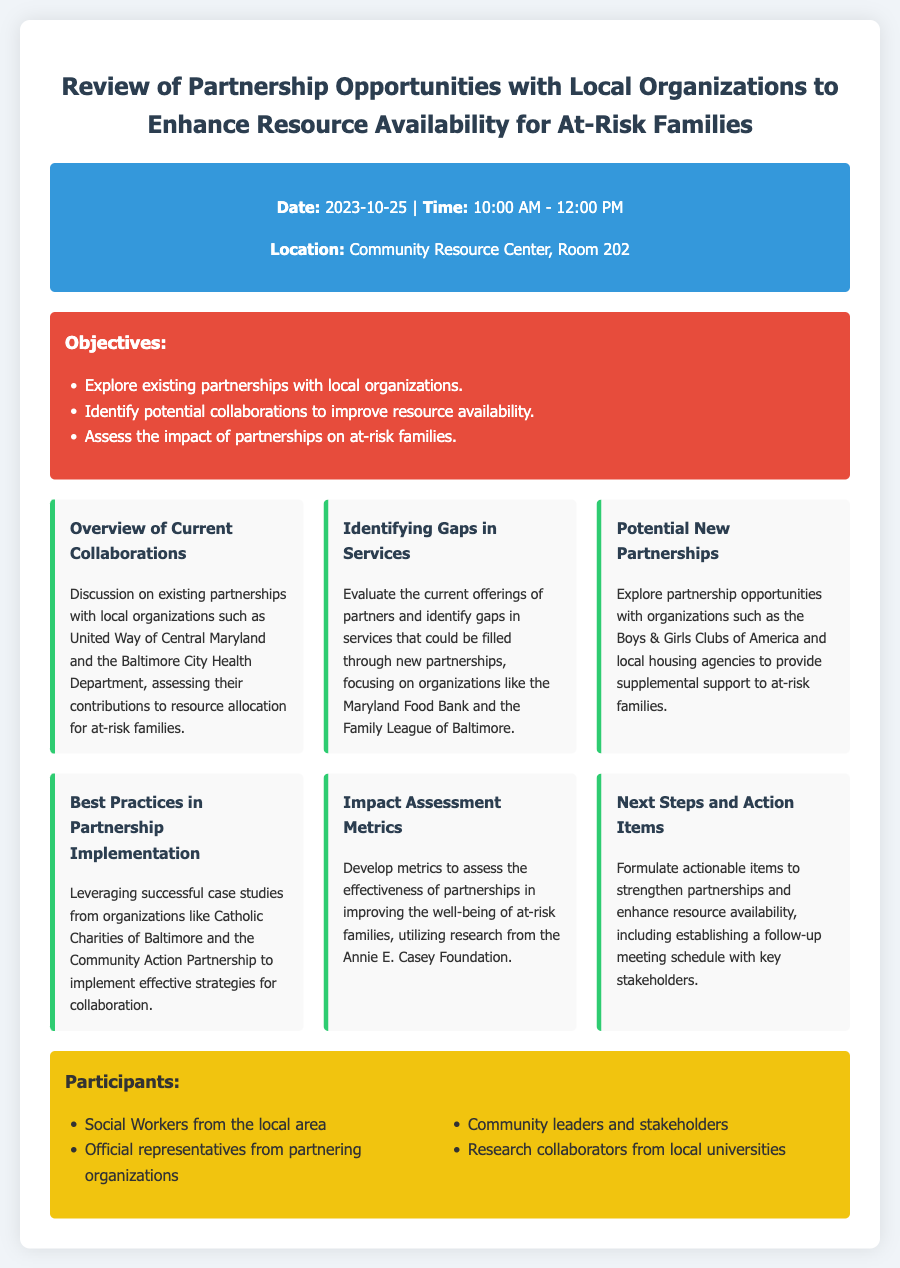What is the date of the meeting? The date of the meeting is mentioned in the document as October 25, 2023.
Answer: October 25, 2023 Where is the meeting taking place? The location of the meeting is provided in the document, which states it will be held at the Community Resource Center, Room 202.
Answer: Community Resource Center, Room 202 Who are some of the participants listed? The document includes a section on participants, stating that social workers, representatives from partnering organizations, community leaders, and research collaborators will attend.
Answer: Social Workers from the local area What is one of the objectives of the meeting? The objectives section outlines several aims of the meeting, one of which is to identify potential collaborations to improve resource availability.
Answer: Identify potential collaborations to improve resource availability What organization is mentioned for impact assessment metrics? The impact assessment metrics section specifies that research from the Annie E. Casey Foundation will be utilized for developing metrics.
Answer: Annie E. Casey Foundation How many topics regarding partnerships are discussed? The document lists six different topics that cover partnership opportunities and assessments.
Answer: Six What is one of the organizations discussed for potential new partnerships? The section on potential new partnerships mentions the Boys & Girls Clubs of America as a possible partner to provide support to at-risk families.
Answer: Boys & Girls Clubs of America What color is used for the objectives section? The document's design features color coding, and the objectives section has a red background.
Answer: Red 